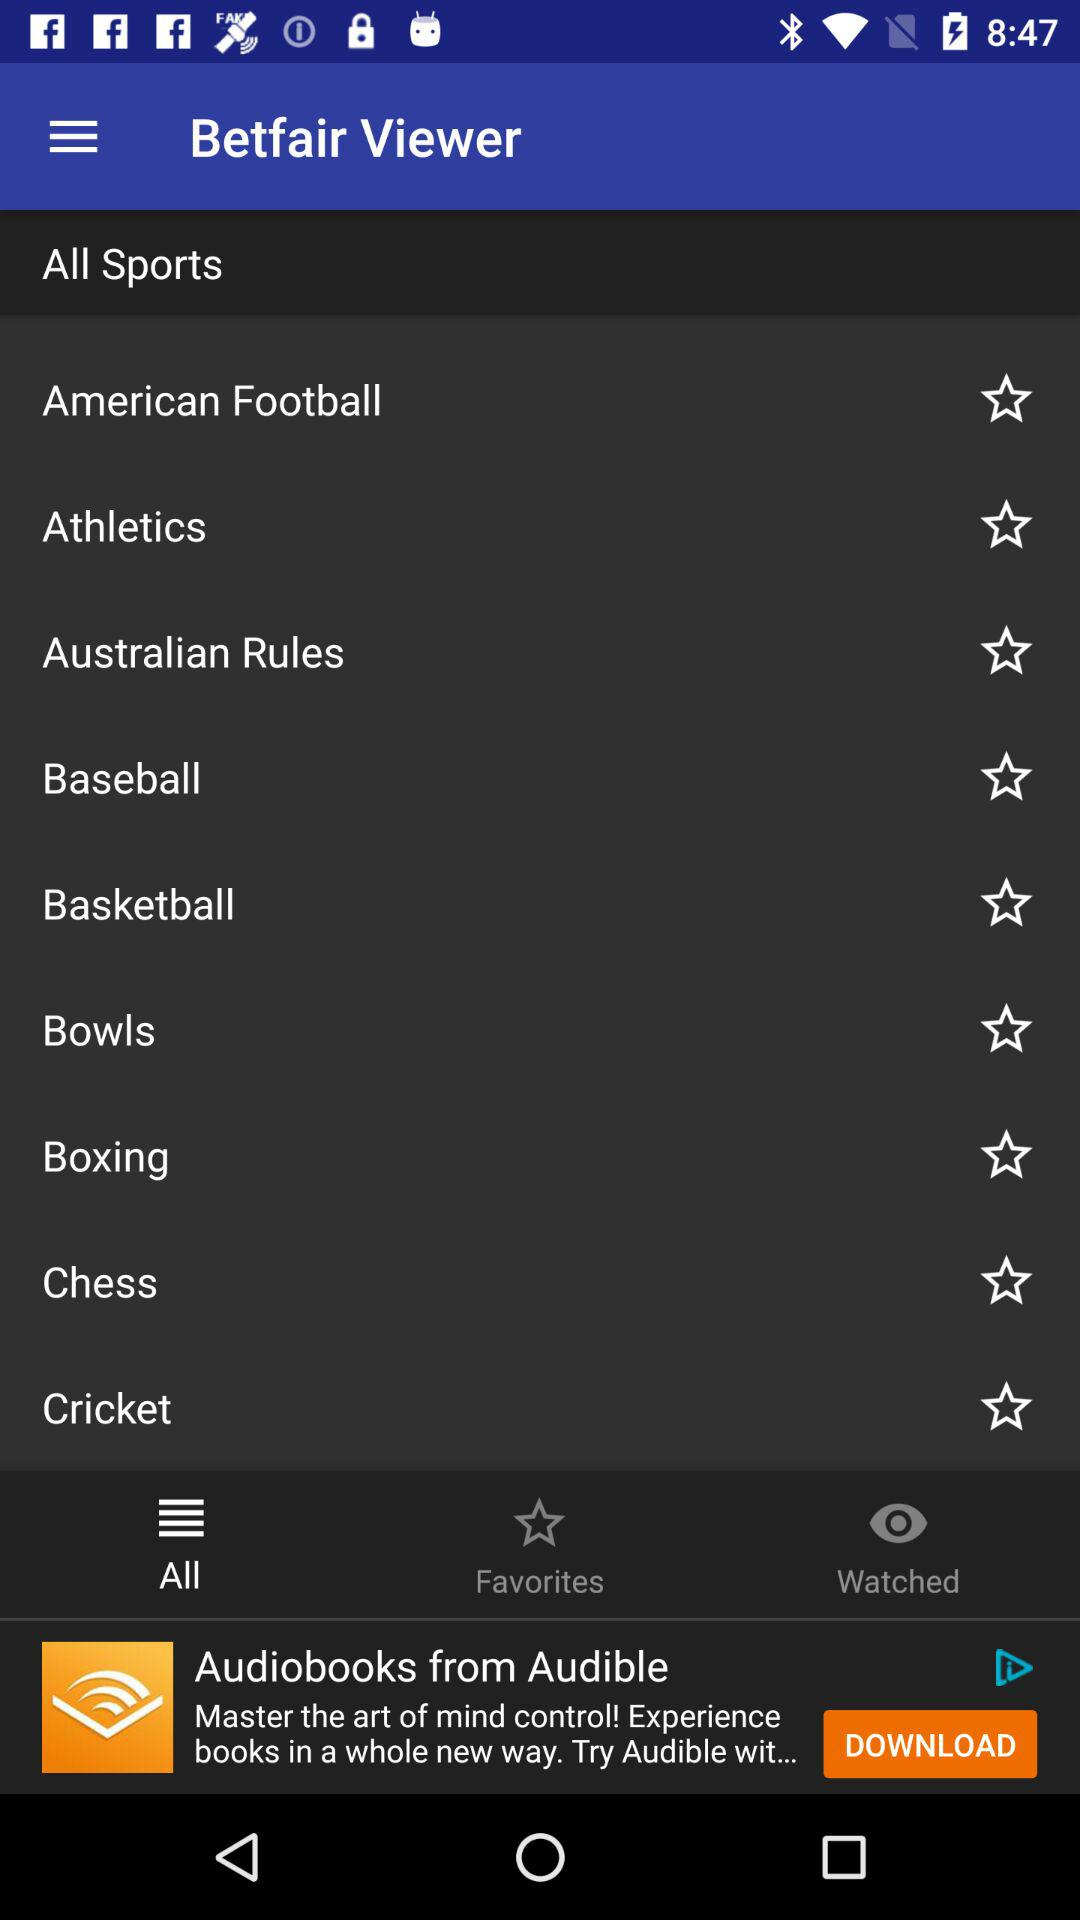Which tab is selected? The selected tab is "All". 